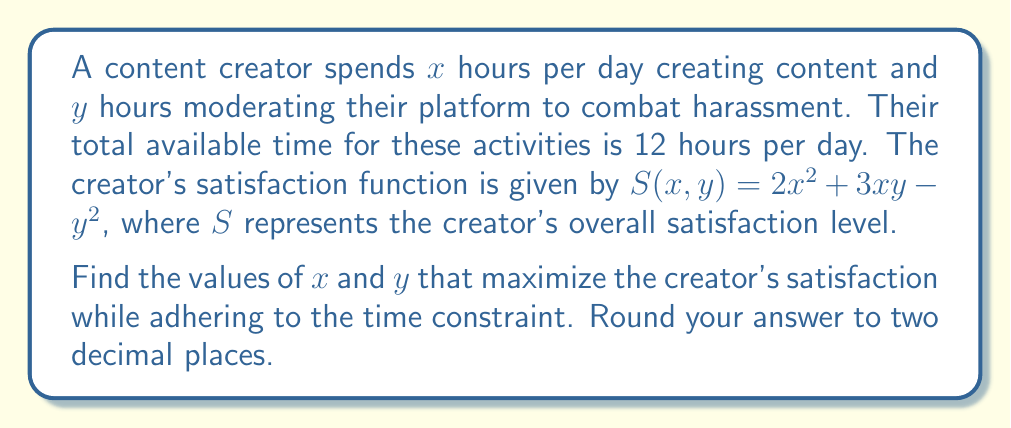Solve this math problem. To solve this optimization problem, we'll use the method of Lagrange multipliers:

1) First, we set up the constraint equation:
   $x + y = 12$

2) Now, we define the Lagrangian function:
   $L(x, y, \lambda) = 2x^2 + 3xy - y^2 - \lambda(x + y - 12)$

3) We take partial derivatives and set them equal to zero:
   $$\frac{\partial L}{\partial x} = 4x + 3y - \lambda = 0$$
   $$\frac{\partial L}{\partial y} = 3x - 2y - \lambda = 0$$
   $$\frac{\partial L}{\partial \lambda} = x + y - 12 = 0$$

4) From the first two equations:
   $4x + 3y = \lambda$ and $3x - 2y = \lambda$
   Subtracting these equations:
   $x + 5y = 0$

5) Substituting this into the constraint equation:
   $x + y = 12$
   $(-5y) + y = 12$
   $-4y = 12$
   $y = -3$

6) Substituting back:
   $x = -5y = -5(-3) = 15$

7) However, since $x$ and $y$ represent time, they can't be negative. The constraint $x + y = 12$ also means $x$ can't exceed 12. Therefore, we need to check the endpoints of our feasible region:

   At $(0, 12)$: $S = 0 + 0 - 144 = -144$
   At $(12, 0)$: $S = 2(144) + 0 - 0 = 288$

8) The maximum satisfaction occurs at $(12, 0)$.
Answer: $x = 12.00$, $y = 0.00$ 